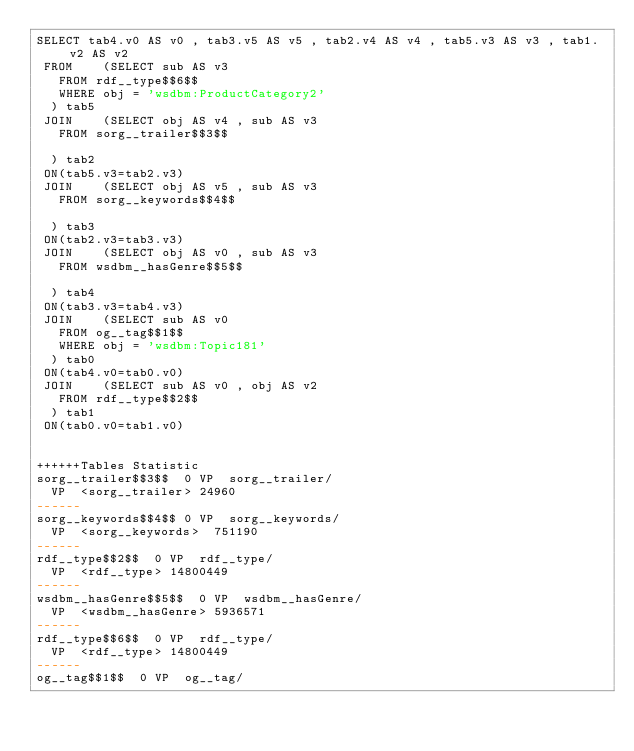Convert code to text. <code><loc_0><loc_0><loc_500><loc_500><_SQL_>SELECT tab4.v0 AS v0 , tab3.v5 AS v5 , tab2.v4 AS v4 , tab5.v3 AS v3 , tab1.v2 AS v2 
 FROM    (SELECT sub AS v3 
	 FROM rdf__type$$6$$ 
	 WHERE obj = 'wsdbm:ProductCategory2'
	) tab5
 JOIN    (SELECT obj AS v4 , sub AS v3 
	 FROM sorg__trailer$$3$$
	
	) tab2
 ON(tab5.v3=tab2.v3)
 JOIN    (SELECT obj AS v5 , sub AS v3 
	 FROM sorg__keywords$$4$$
	
	) tab3
 ON(tab2.v3=tab3.v3)
 JOIN    (SELECT obj AS v0 , sub AS v3 
	 FROM wsdbm__hasGenre$$5$$
	
	) tab4
 ON(tab3.v3=tab4.v3)
 JOIN    (SELECT sub AS v0 
	 FROM og__tag$$1$$ 
	 WHERE obj = 'wsdbm:Topic181'
	) tab0
 ON(tab4.v0=tab0.v0)
 JOIN    (SELECT sub AS v0 , obj AS v2 
	 FROM rdf__type$$2$$
	) tab1
 ON(tab0.v0=tab1.v0)


++++++Tables Statistic
sorg__trailer$$3$$	0	VP	sorg__trailer/
	VP	<sorg__trailer>	24960
------
sorg__keywords$$4$$	0	VP	sorg__keywords/
	VP	<sorg__keywords>	751190
------
rdf__type$$2$$	0	VP	rdf__type/
	VP	<rdf__type>	14800449
------
wsdbm__hasGenre$$5$$	0	VP	wsdbm__hasGenre/
	VP	<wsdbm__hasGenre>	5936571
------
rdf__type$$6$$	0	VP	rdf__type/
	VP	<rdf__type>	14800449
------
og__tag$$1$$	0	VP	og__tag/</code> 